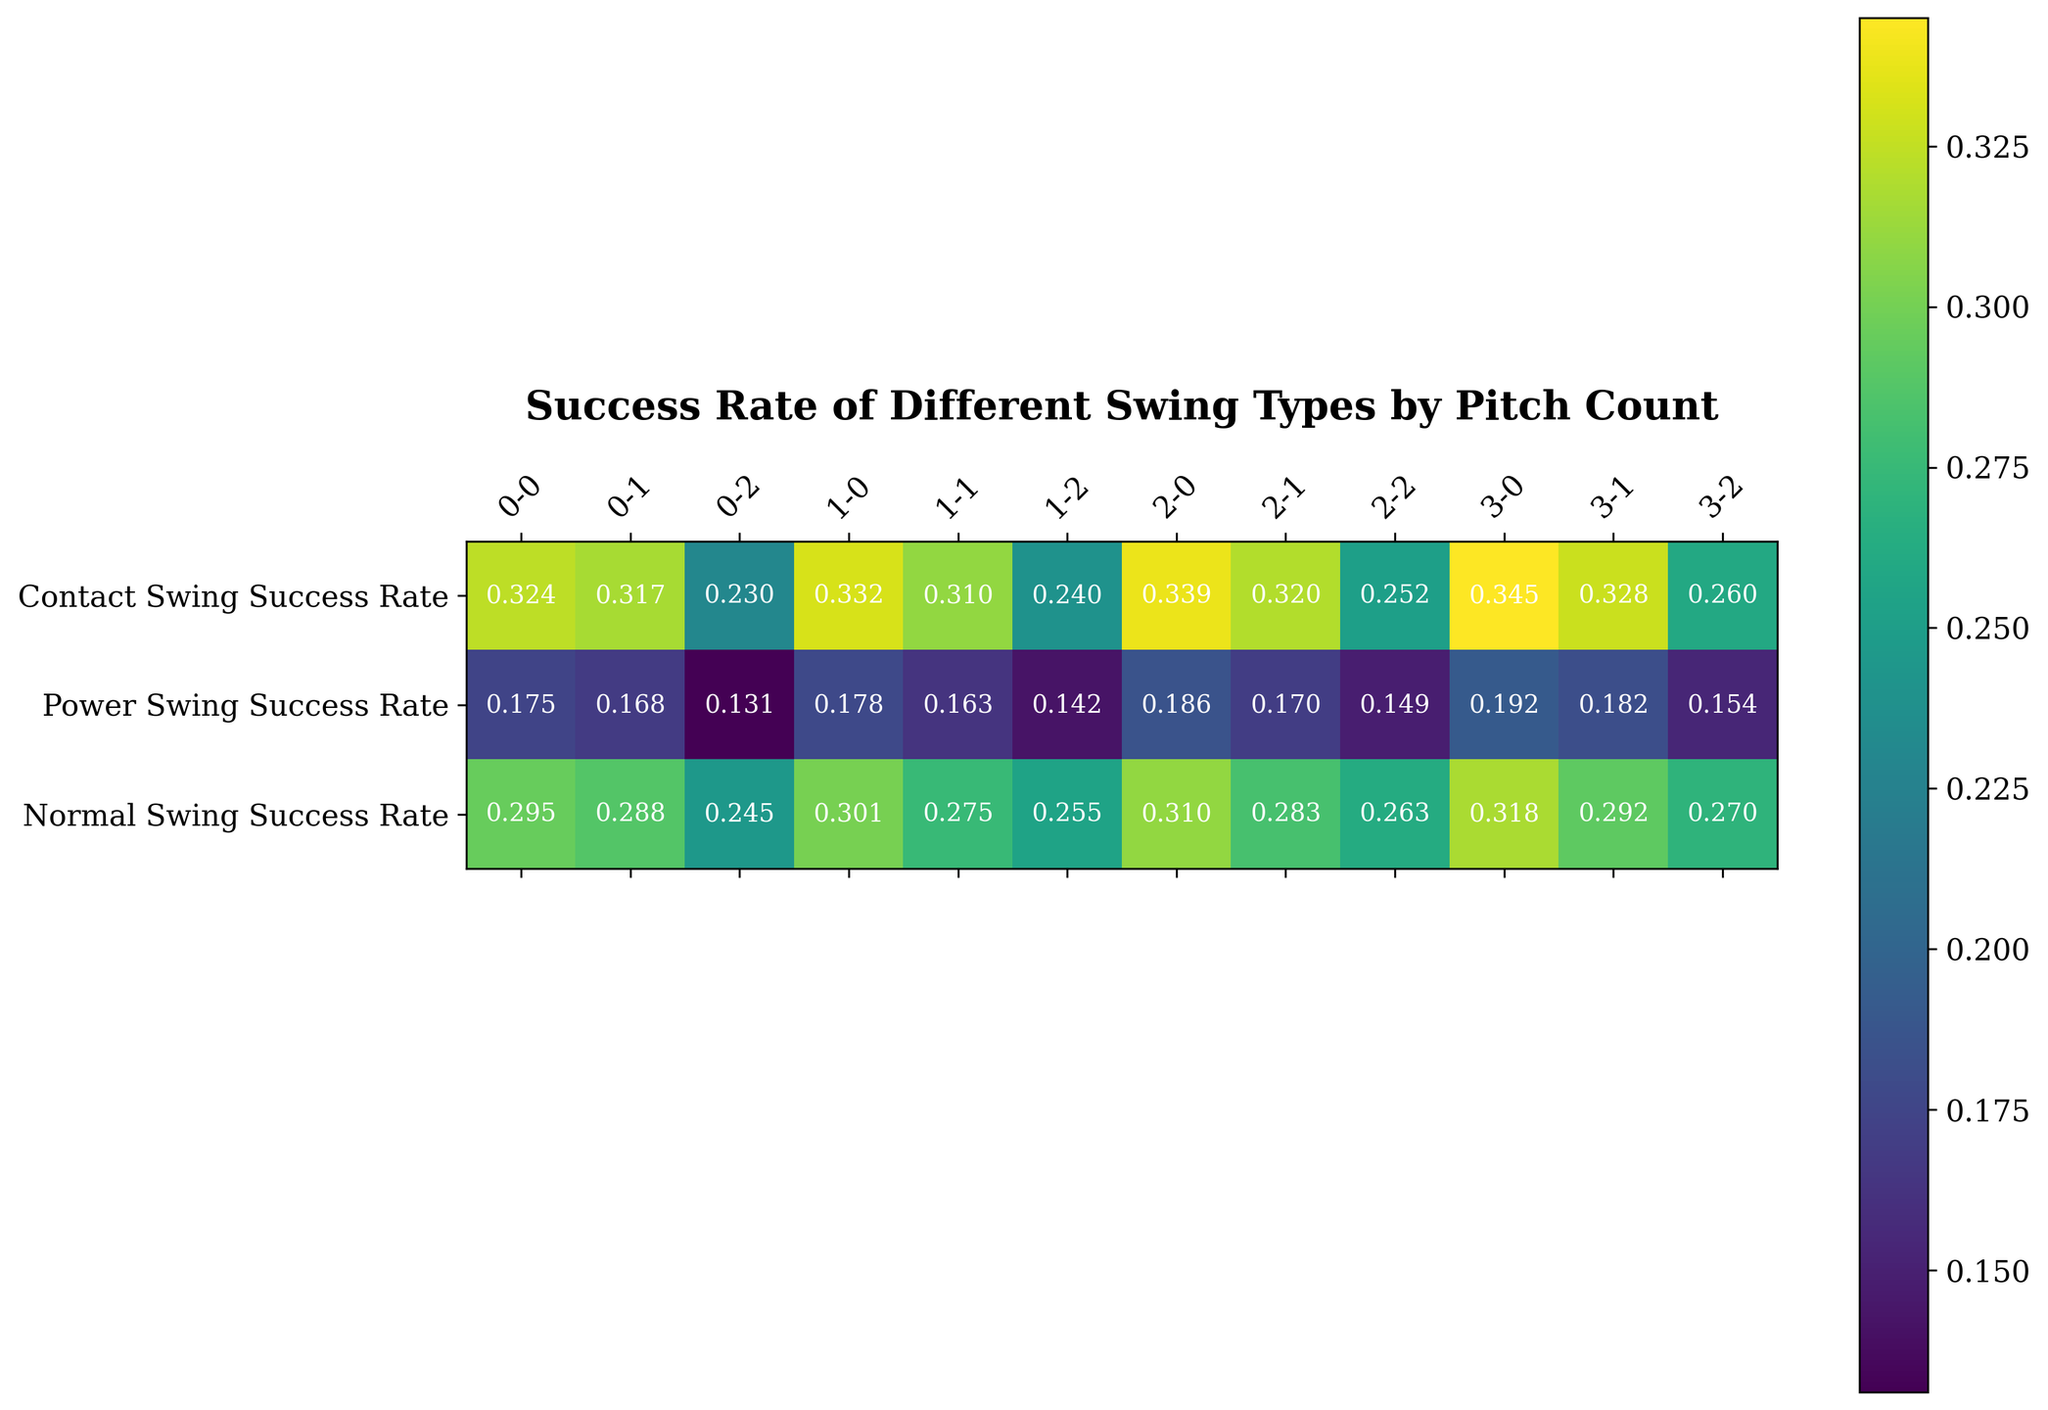Which swing type has the highest success rate for a 3-0 pitch count? Looking at the row labeled "3-0" in the heatmap, the success rates for Contact, Power, and Normal swings are shown. The highest value among these is 0.345 for Contact Swing.
Answer: Contact Swing What is the difference in success rate between Contact and Power swings for a 1-2 pitch count? Compare the values for Contact Swing Success Rate (0.240) and Power Swing Success Rate (0.142) in the "1-2" row. Subtract the Power Swing rate from the Contact Swing rate: 0.240 - 0.142.
Answer: 0.098 What is the average success rate for Normal swings across all pitch counts? Sum the Normal Swing Success Rates across all pitch counts and divide by the number of pitch counts. (0.295 + 0.288 + 0.245 + 0.301 + 0.275 + 0.255 + 0.310 + 0.283 + 0.263 + 0.318 + 0.292 + 0.270) / 12 = 0.285.
Answer: 0.285 Which swing type has the highest average success rate over all pitch counts? Calculate the average for each swing type: Contact (0.324+0.317+0.230+0.332+0.310+0.240+0.339+0.320+0.252+0.345+0.328+0.260)/12 = 0.310, Power (0.175+0.168+0.131+0.178+0.163+0.142+0.186+0.170+0.149+0.192+0.182+0.154)/12 = 0.167, Normal (0.295+0.288+0.245+0.301+0.275+0.255+0.310+0.283+0.263+0.318+0.292+0.270)/12 = 0.285. The highest average is for Contact swings.
Answer: Contact Swing For which pitch count is the success rate the lowest for Normal swings? Identify the lowest value in the Normal Swing Success Rate row, which is in the "0-2" pitch count, showing 0.245.
Answer: 0-2 Is there any instance where the success rate for a Power swing is higher than both Contact and Normal swings? Check each pitch count row to see if Power Swing Success Rate is higher than both Contact and Normal Swing rates. There are no such instances.
Answer: No Which swing type shows the most consistent (least variation) success rate across all pitch counts? Calculate the range (maximum - minimum) for each swing type. Contact (0.345 - 0.230 = 0.115), Power (0.192 - 0.131 = 0.061), Normal (0.318 - 0.245 = 0.073). Power shows the least variation.
Answer: Power Swing What is the success rate of a Contact swing at a 2-0 pitch count, and how does it compare to other swing types at the same count? Look at the "2-0" row; Contact Swing Success Rate is 0.339. Power Swing (0.186) and Normal Swing (0.310) are both lower.
Answer: 0.339, higher 